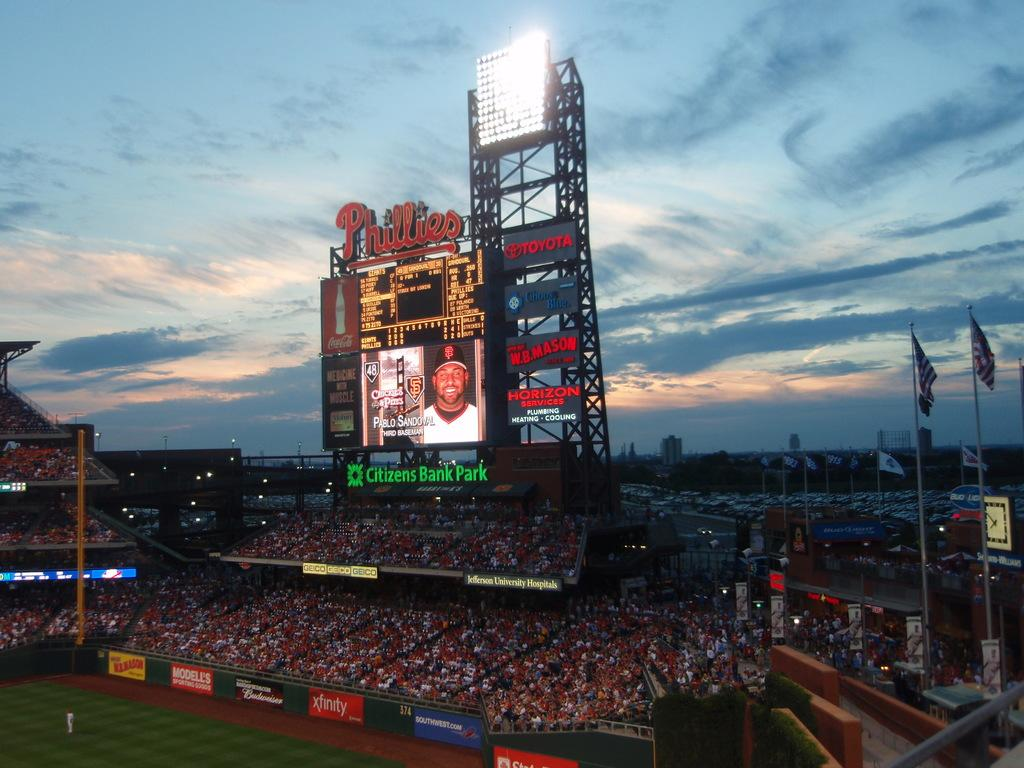<image>
Relay a brief, clear account of the picture shown. Citizens Bank Park is a sponsor of the large screen. 